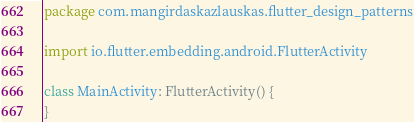<code> <loc_0><loc_0><loc_500><loc_500><_Kotlin_>package com.mangirdaskazlauskas.flutter_design_patterns

import io.flutter.embedding.android.FlutterActivity

class MainActivity: FlutterActivity() {
}
</code> 